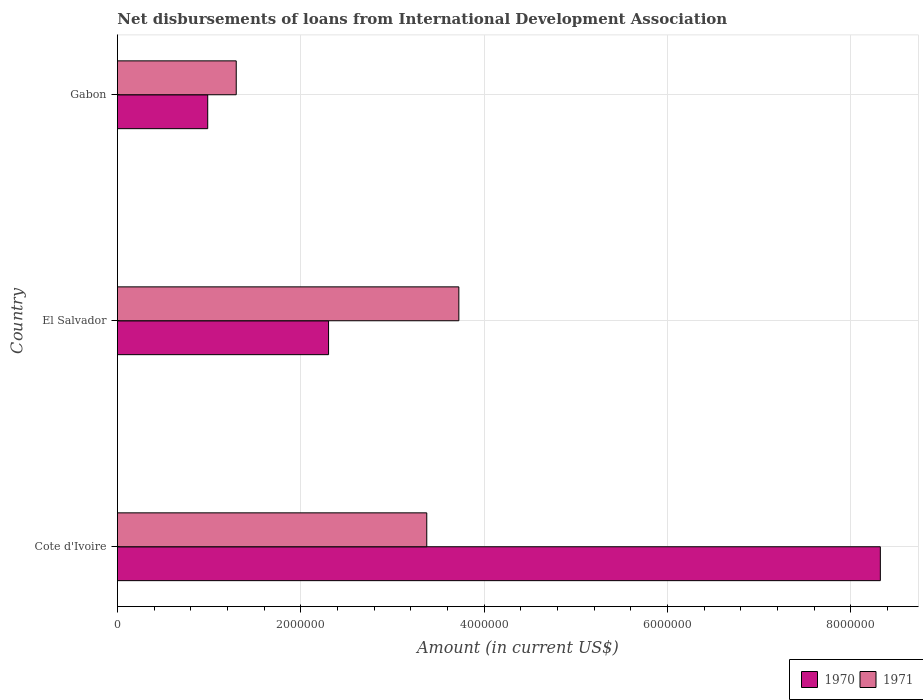Are the number of bars on each tick of the Y-axis equal?
Offer a terse response. Yes. How many bars are there on the 1st tick from the top?
Give a very brief answer. 2. What is the label of the 1st group of bars from the top?
Your answer should be compact. Gabon. What is the amount of loans disbursed in 1971 in El Salvador?
Offer a very short reply. 3.72e+06. Across all countries, what is the maximum amount of loans disbursed in 1970?
Give a very brief answer. 8.32e+06. Across all countries, what is the minimum amount of loans disbursed in 1970?
Provide a succinct answer. 9.85e+05. In which country was the amount of loans disbursed in 1971 maximum?
Ensure brevity in your answer.  El Salvador. In which country was the amount of loans disbursed in 1970 minimum?
Offer a terse response. Gabon. What is the total amount of loans disbursed in 1971 in the graph?
Provide a short and direct response. 8.39e+06. What is the difference between the amount of loans disbursed in 1970 in Cote d'Ivoire and that in El Salvador?
Give a very brief answer. 6.02e+06. What is the difference between the amount of loans disbursed in 1971 in El Salvador and the amount of loans disbursed in 1970 in Cote d'Ivoire?
Give a very brief answer. -4.60e+06. What is the average amount of loans disbursed in 1970 per country?
Provide a succinct answer. 3.87e+06. What is the difference between the amount of loans disbursed in 1971 and amount of loans disbursed in 1970 in Cote d'Ivoire?
Ensure brevity in your answer.  -4.95e+06. In how many countries, is the amount of loans disbursed in 1971 greater than 3200000 US$?
Keep it short and to the point. 2. What is the ratio of the amount of loans disbursed in 1971 in Cote d'Ivoire to that in El Salvador?
Give a very brief answer. 0.91. Is the difference between the amount of loans disbursed in 1971 in Cote d'Ivoire and El Salvador greater than the difference between the amount of loans disbursed in 1970 in Cote d'Ivoire and El Salvador?
Offer a very short reply. No. What is the difference between the highest and the second highest amount of loans disbursed in 1971?
Provide a succinct answer. 3.50e+05. What is the difference between the highest and the lowest amount of loans disbursed in 1971?
Keep it short and to the point. 2.43e+06. What does the 2nd bar from the bottom in El Salvador represents?
Offer a terse response. 1971. What is the difference between two consecutive major ticks on the X-axis?
Ensure brevity in your answer.  2.00e+06. Are the values on the major ticks of X-axis written in scientific E-notation?
Keep it short and to the point. No. Does the graph contain any zero values?
Offer a terse response. No. Where does the legend appear in the graph?
Provide a succinct answer. Bottom right. How are the legend labels stacked?
Your response must be concise. Horizontal. What is the title of the graph?
Offer a very short reply. Net disbursements of loans from International Development Association. Does "2003" appear as one of the legend labels in the graph?
Provide a succinct answer. No. What is the Amount (in current US$) of 1970 in Cote d'Ivoire?
Give a very brief answer. 8.32e+06. What is the Amount (in current US$) of 1971 in Cote d'Ivoire?
Provide a short and direct response. 3.37e+06. What is the Amount (in current US$) in 1970 in El Salvador?
Keep it short and to the point. 2.30e+06. What is the Amount (in current US$) in 1971 in El Salvador?
Provide a short and direct response. 3.72e+06. What is the Amount (in current US$) in 1970 in Gabon?
Ensure brevity in your answer.  9.85e+05. What is the Amount (in current US$) of 1971 in Gabon?
Make the answer very short. 1.30e+06. Across all countries, what is the maximum Amount (in current US$) of 1970?
Keep it short and to the point. 8.32e+06. Across all countries, what is the maximum Amount (in current US$) in 1971?
Offer a very short reply. 3.72e+06. Across all countries, what is the minimum Amount (in current US$) in 1970?
Offer a terse response. 9.85e+05. Across all countries, what is the minimum Amount (in current US$) in 1971?
Your answer should be very brief. 1.30e+06. What is the total Amount (in current US$) in 1970 in the graph?
Make the answer very short. 1.16e+07. What is the total Amount (in current US$) in 1971 in the graph?
Make the answer very short. 8.39e+06. What is the difference between the Amount (in current US$) in 1970 in Cote d'Ivoire and that in El Salvador?
Your answer should be compact. 6.02e+06. What is the difference between the Amount (in current US$) of 1971 in Cote d'Ivoire and that in El Salvador?
Ensure brevity in your answer.  -3.50e+05. What is the difference between the Amount (in current US$) in 1970 in Cote d'Ivoire and that in Gabon?
Offer a very short reply. 7.34e+06. What is the difference between the Amount (in current US$) in 1971 in Cote d'Ivoire and that in Gabon?
Keep it short and to the point. 2.08e+06. What is the difference between the Amount (in current US$) of 1970 in El Salvador and that in Gabon?
Ensure brevity in your answer.  1.32e+06. What is the difference between the Amount (in current US$) in 1971 in El Salvador and that in Gabon?
Your answer should be compact. 2.43e+06. What is the difference between the Amount (in current US$) of 1970 in Cote d'Ivoire and the Amount (in current US$) of 1971 in El Salvador?
Offer a very short reply. 4.60e+06. What is the difference between the Amount (in current US$) of 1970 in Cote d'Ivoire and the Amount (in current US$) of 1971 in Gabon?
Ensure brevity in your answer.  7.02e+06. What is the difference between the Amount (in current US$) in 1970 in El Salvador and the Amount (in current US$) in 1971 in Gabon?
Give a very brief answer. 1.01e+06. What is the average Amount (in current US$) of 1970 per country?
Give a very brief answer. 3.87e+06. What is the average Amount (in current US$) of 1971 per country?
Provide a short and direct response. 2.80e+06. What is the difference between the Amount (in current US$) of 1970 and Amount (in current US$) of 1971 in Cote d'Ivoire?
Make the answer very short. 4.95e+06. What is the difference between the Amount (in current US$) of 1970 and Amount (in current US$) of 1971 in El Salvador?
Keep it short and to the point. -1.42e+06. What is the difference between the Amount (in current US$) in 1970 and Amount (in current US$) in 1971 in Gabon?
Give a very brief answer. -3.11e+05. What is the ratio of the Amount (in current US$) of 1970 in Cote d'Ivoire to that in El Salvador?
Provide a succinct answer. 3.61. What is the ratio of the Amount (in current US$) of 1971 in Cote d'Ivoire to that in El Salvador?
Offer a terse response. 0.91. What is the ratio of the Amount (in current US$) in 1970 in Cote d'Ivoire to that in Gabon?
Your answer should be very brief. 8.45. What is the ratio of the Amount (in current US$) of 1971 in Cote d'Ivoire to that in Gabon?
Provide a succinct answer. 2.6. What is the ratio of the Amount (in current US$) of 1970 in El Salvador to that in Gabon?
Provide a short and direct response. 2.34. What is the ratio of the Amount (in current US$) of 1971 in El Salvador to that in Gabon?
Your answer should be very brief. 2.87. What is the difference between the highest and the second highest Amount (in current US$) of 1970?
Ensure brevity in your answer.  6.02e+06. What is the difference between the highest and the lowest Amount (in current US$) of 1970?
Offer a very short reply. 7.34e+06. What is the difference between the highest and the lowest Amount (in current US$) of 1971?
Your response must be concise. 2.43e+06. 